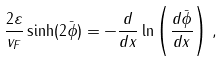Convert formula to latex. <formula><loc_0><loc_0><loc_500><loc_500>\frac { 2 \varepsilon } { v _ { F } } \sinh ( 2 { \bar { \phi } } ) = - \frac { d } { d x } \ln \left ( \frac { d { \bar { \phi } } } { d x } \right ) \, ,</formula> 